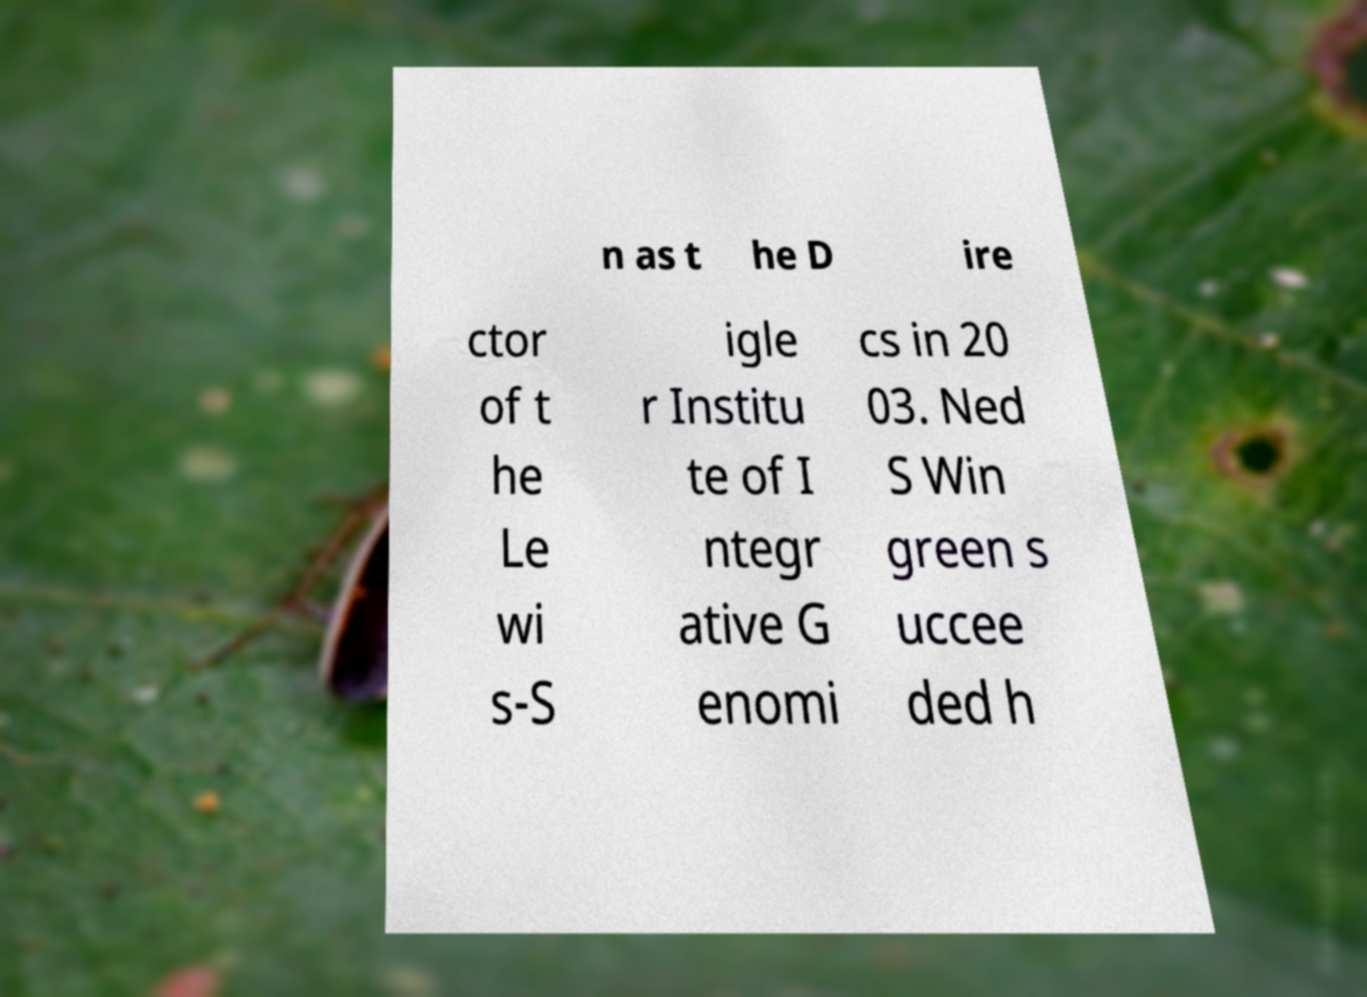Can you read and provide the text displayed in the image?This photo seems to have some interesting text. Can you extract and type it out for me? n as t he D ire ctor of t he Le wi s-S igle r Institu te of I ntegr ative G enomi cs in 20 03. Ned S Win green s uccee ded h 